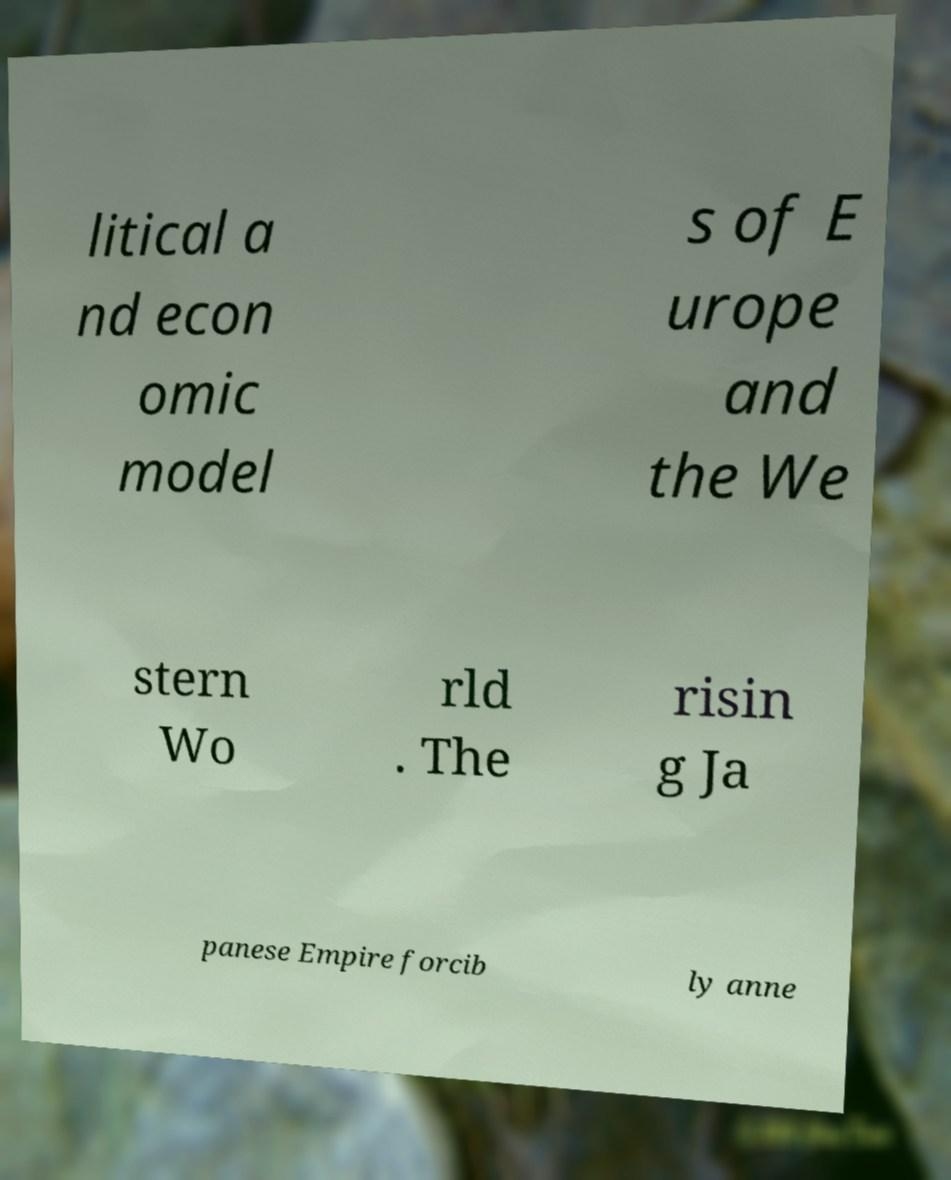Could you extract and type out the text from this image? litical a nd econ omic model s of E urope and the We stern Wo rld . The risin g Ja panese Empire forcib ly anne 